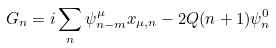Convert formula to latex. <formula><loc_0><loc_0><loc_500><loc_500>G _ { n } = i \sum _ { n } \psi _ { n - m } ^ { \mu } x _ { \mu , n } - 2 Q ( n + 1 ) \psi _ { n } ^ { 0 }</formula> 